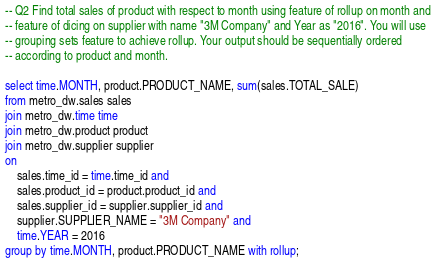Convert code to text. <code><loc_0><loc_0><loc_500><loc_500><_SQL_>-- Q2 Find total sales of product with respect to month using feature of rollup on month and
-- feature of dicing on supplier with name "3M Company" and Year as "2016". You will use
-- grouping sets feature to achieve rollup. Your output should be sequentially ordered
-- according to product and month.

select time.MONTH, product.PRODUCT_NAME, sum(sales.TOTAL_SALE)
from metro_dw.sales sales
join metro_dw.time time
join metro_dw.product product
join metro_dw.supplier supplier
on 
	sales.time_id = time.time_id and
    sales.product_id = product.product_id and
	sales.supplier_id = supplier.supplier_id and
    supplier.SUPPLIER_NAME = "3M Company" and 
    time.YEAR = 2016
group by time.MONTH, product.PRODUCT_NAME with rollup;</code> 